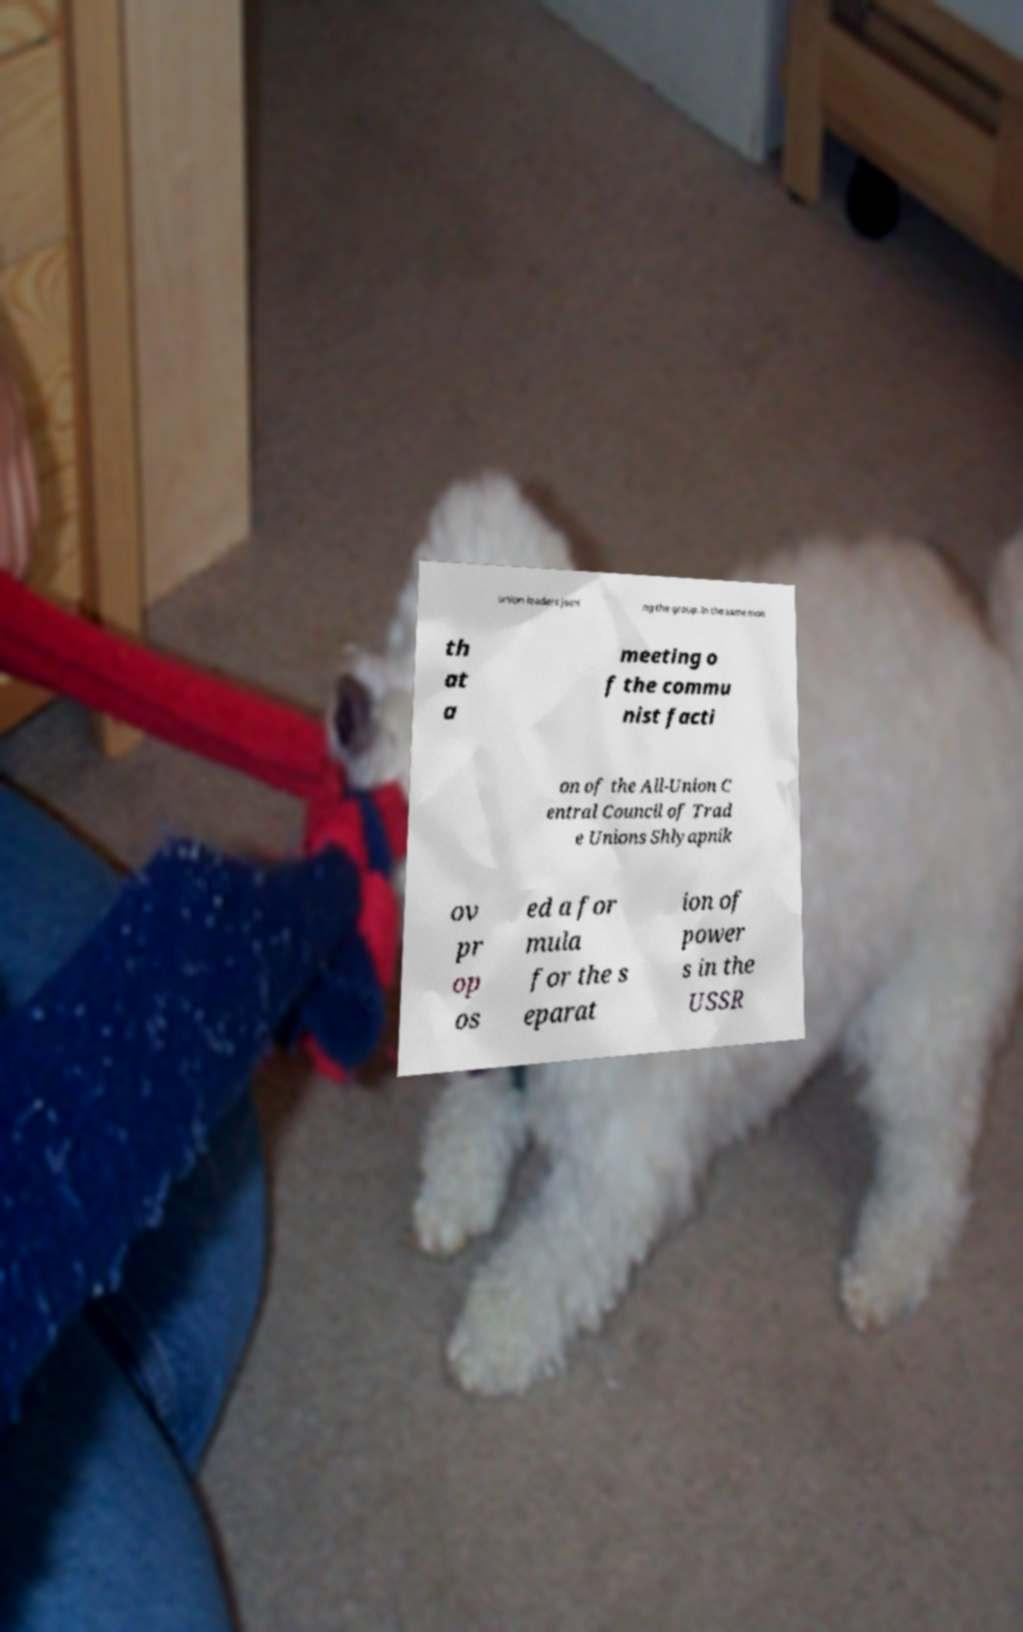What messages or text are displayed in this image? I need them in a readable, typed format. union leaders joini ng the group. In the same mon th at a meeting o f the commu nist facti on of the All-Union C entral Council of Trad e Unions Shlyapnik ov pr op os ed a for mula for the s eparat ion of power s in the USSR 